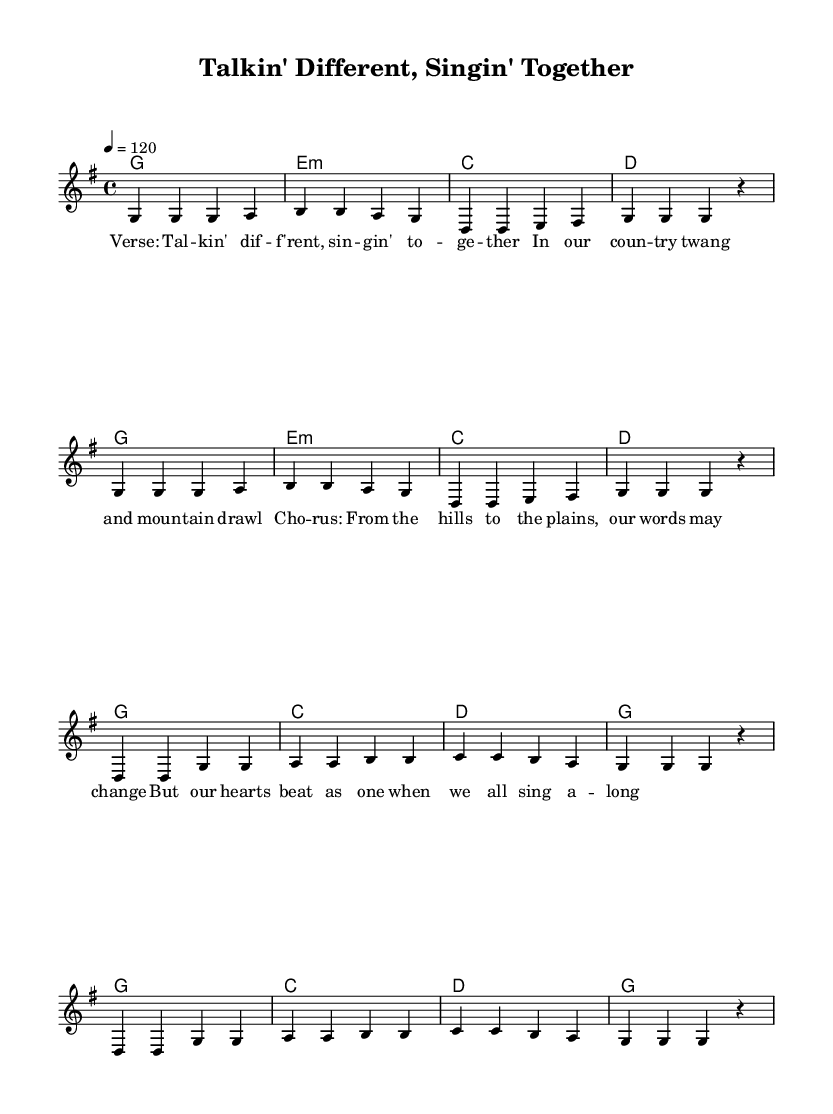What is the key signature of this music? The key signature is G major, which has one sharp (F#). We determine this by looking at the first line of the score where the key signature is indicated.
Answer: G major What is the time signature of this piece? The time signature is 4/4, as indicated at the beginning of the score. It shows that there are four beats in each measure and the quarter note gets one beat.
Answer: 4/4 What is the tempo marking for this song? The tempo marking is 120 beats per minute, indicated by "4 = 120" in the tempo section of the global settings. This means the piece should be played at a moderate fast pace.
Answer: 120 How many measures are there in the verse? The verse consists of 8 measures in total, as seen in the melody section. Each line of the verse contains 4 measures, and there are 2 lines.
Answer: 8 What chord follows the first line of the verse? The chord that follows the first line of the verse is E minor (e:m). This determination is made by looking at the harmony section immediately following the verse's melody mapping.
Answer: E minor What is the highest note in the melody? The highest note in the melody is B. By examining the melody in the provided score, we see that the note B appears, and it is the most elevated pitch compared to others.
Answer: B How does the chorus differ from the verse rhythmically? The chorus features a slightly more emphatic rhythm as it has four measures that repeat with a similar chord progression, while the verse has a more consistent rhythm throughout. This difference emphasizes the celebratory nature of the chorus.
Answer: More emphatic 